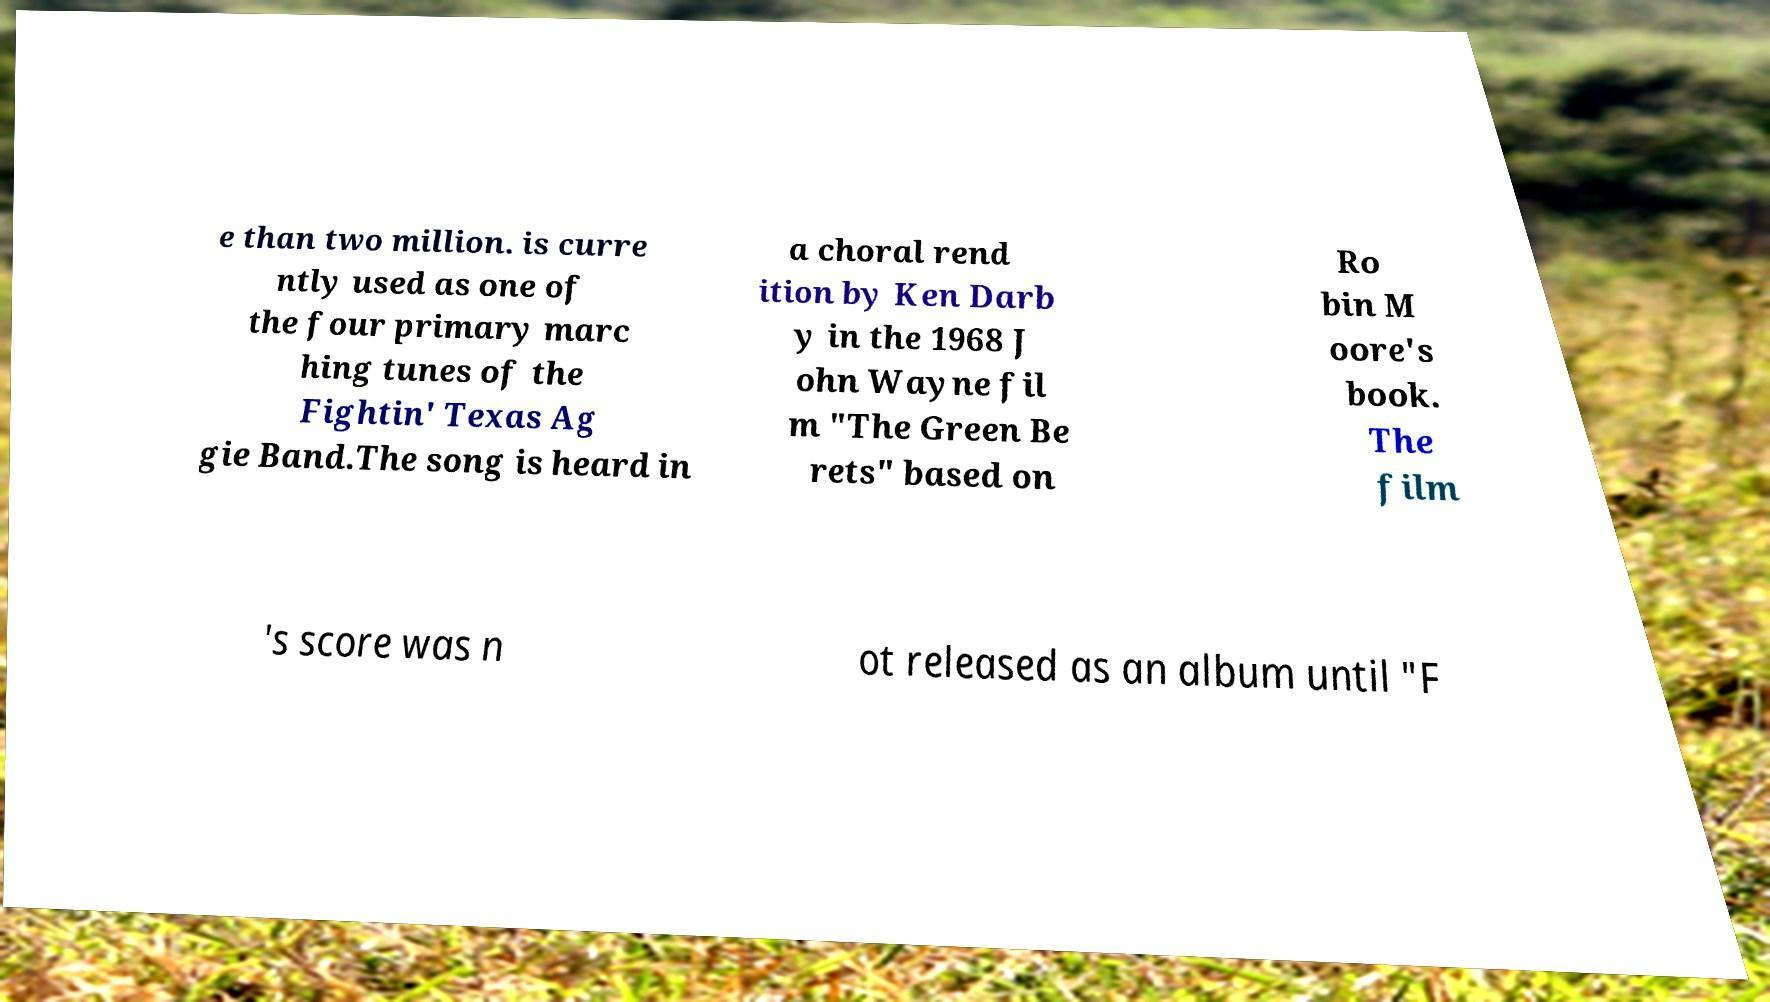There's text embedded in this image that I need extracted. Can you transcribe it verbatim? e than two million. is curre ntly used as one of the four primary marc hing tunes of the Fightin' Texas Ag gie Band.The song is heard in a choral rend ition by Ken Darb y in the 1968 J ohn Wayne fil m "The Green Be rets" based on Ro bin M oore's book. The film 's score was n ot released as an album until "F 